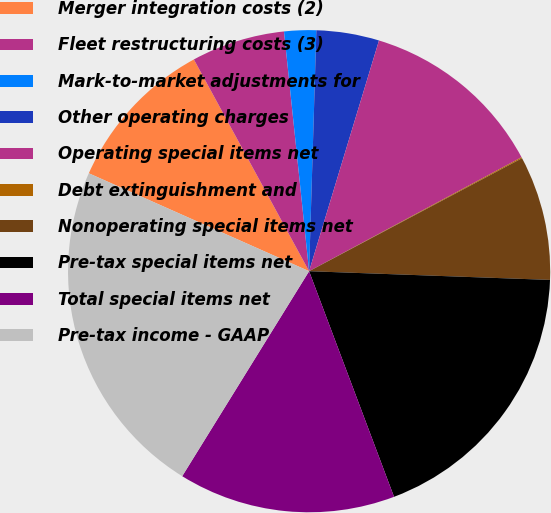Convert chart to OTSL. <chart><loc_0><loc_0><loc_500><loc_500><pie_chart><fcel>Merger integration costs (2)<fcel>Fleet restructuring costs (3)<fcel>Mark-to-market adjustments for<fcel>Other operating charges<fcel>Operating special items net<fcel>Debt extinguishment and<fcel>Nonoperating special items net<fcel>Pre-tax special items net<fcel>Total special items net<fcel>Pre-tax income - GAAP<nl><fcel>10.41%<fcel>6.27%<fcel>2.14%<fcel>4.2%<fcel>12.48%<fcel>0.07%<fcel>8.34%<fcel>18.69%<fcel>14.55%<fcel>22.83%<nl></chart> 